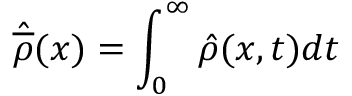<formula> <loc_0><loc_0><loc_500><loc_500>\hat { \overline { \rho } } ( x ) = \int _ { 0 } ^ { \infty } \hat { \rho } ( x , t ) d t</formula> 